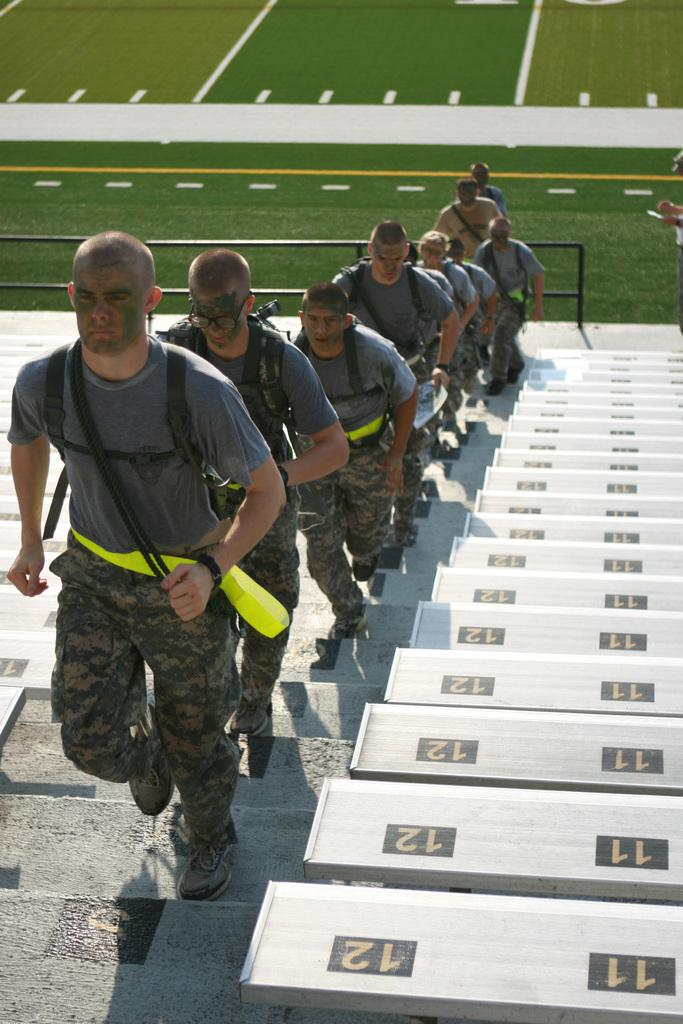What is happening in the image involving a group of people? The people in the image are climbing stairs in a line. What are the people wearing? The people in the image are wearing clothes. What can be seen on the right side of the image? There are benches on the right side of the image. What type of field is visible in the image? There is no field visible in the image; it features a group of people climbing stairs in a line. What are the people talking about while climbing the stairs? The image does not provide information about what the people are talking about, as it only shows them climbing stairs in a line. 